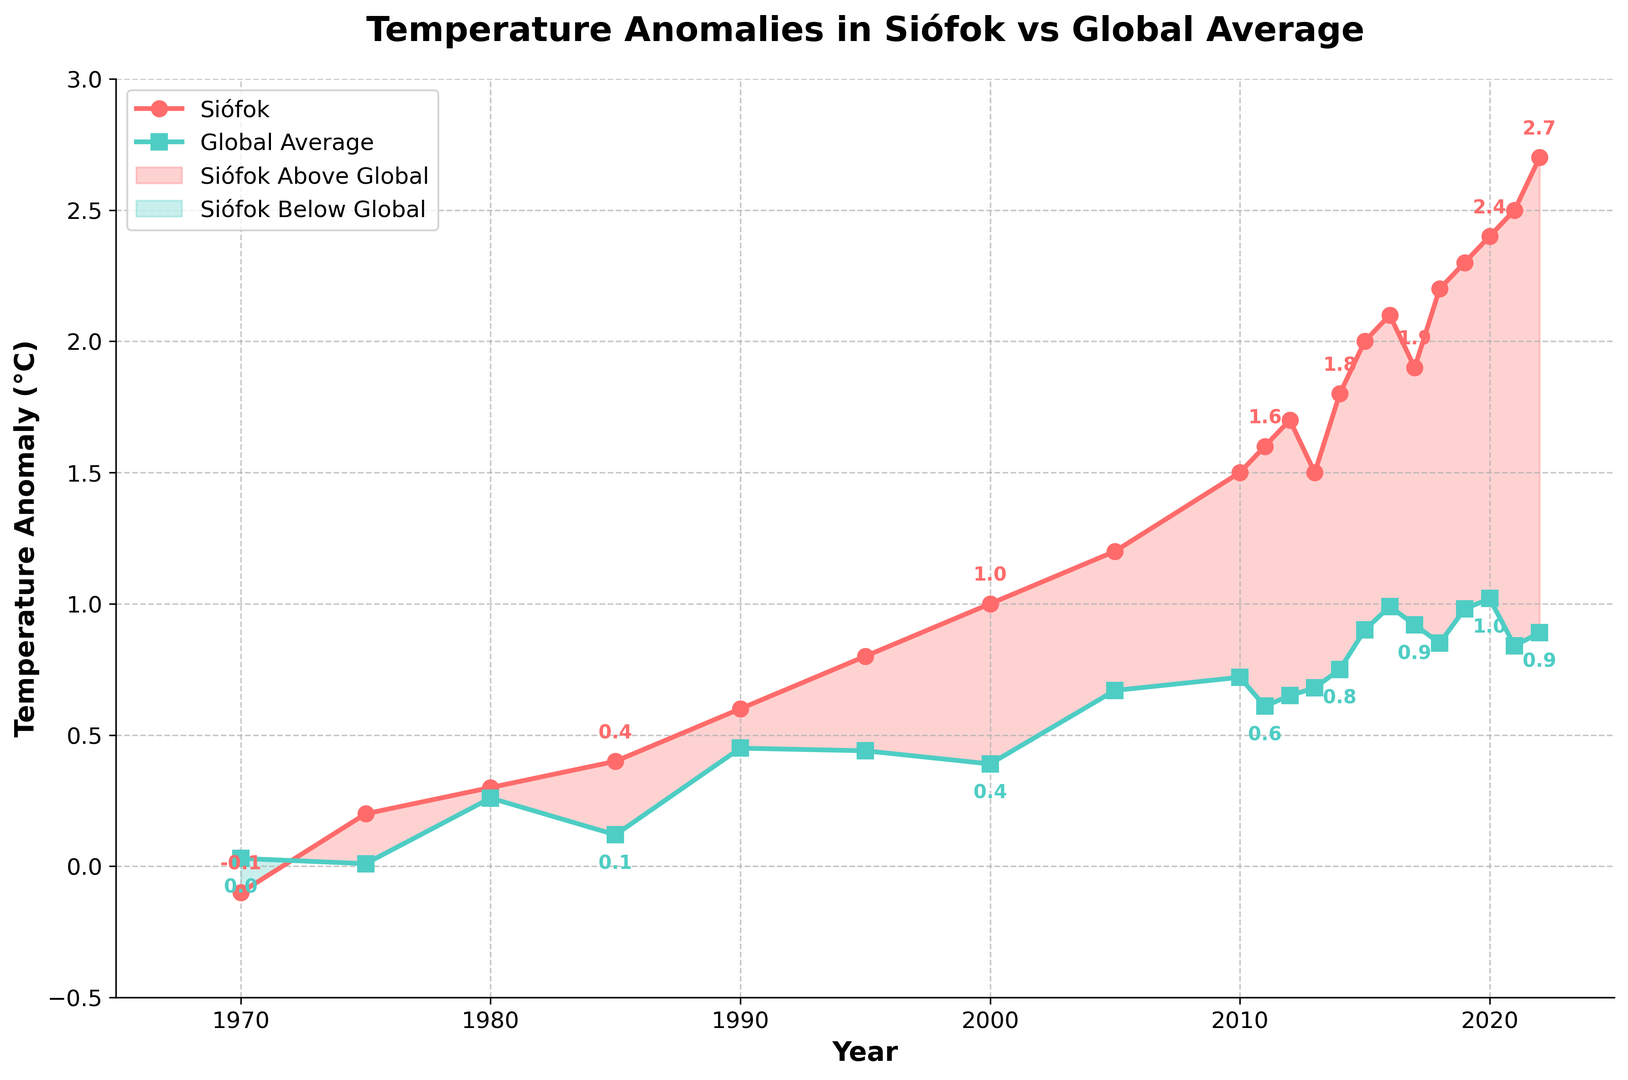What is the temperature anomaly of Siófok in 2022? The value can be read directly from the plot. The anomaly for Siófok in 2022 is annotated with the label "2.7"
Answer: 2.7 How does the temperature anomaly in Siófok in 1980 compare to the global average in the same year? In 1980, Siófok has an anomaly of 0.3 (annotated in red) while the global average is 0.26 (annotated in green). Since 0.3 is greater than 0.26
Answer: Siófok > Global What is the difference in temperature anomalies between Siófok and the global average in 2015? In 2015, Siófok has an anomaly of 2.0 and the global average is 0.90. The difference is 2.0 - 0.90
Answer: 1.1 Which year showed the highest anomaly for Siófok and what was the value? Among all the years plotted, the highest anomaly for Siófok is 2.7 in 2022
Answer: 2022, 2.7 In what years did the temperature anomaly in Siófok equal to or exceed 1.5? The years where the anomaly in Siófok is greater than or equal to 1.5 are 2010, 2011, 2012, 2013, 2014, 2015, 2016, 2017, 2018, 2019, 2020, 2021, and 2022
Answer: 2010-2022 (except 2013, 2017) What is the average temperature anomaly for Siófok between 1970 and 1985? The anomalies in this period are: -0.1, 0.2, 0.3, 0.4. The sum is -0.1 + 0.2 + 0.3 + 0.4 = 0.8, and there are 4 years
Answer: 0.20 In which year did the global average temperature anomaly first exceed 0.9? From the plot, the global average anomaly first exceeds 0.9 in 2015
Answer: 2015 What was the temperature anomaly trend for both Siófok and the global average from 2000 to 2020? Observing the plot from 2000 to 2020, both Siófok and the global average show an increasing trend. The Siófok anomaly starts at 1.0 and goes up to 2.4, while the global average goes from around 0.39 to 1.02
Answer: Increasing 